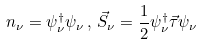Convert formula to latex. <formula><loc_0><loc_0><loc_500><loc_500>n _ { \nu } = \psi ^ { \dagger } _ { \nu } \psi _ { \nu } \, , \, \vec { S } _ { \nu } = \frac { 1 } { 2 } \psi ^ { \dagger } _ { \nu } \vec { \tau } \psi _ { \nu }</formula> 